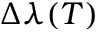<formula> <loc_0><loc_0><loc_500><loc_500>\Delta \lambda ( T )</formula> 